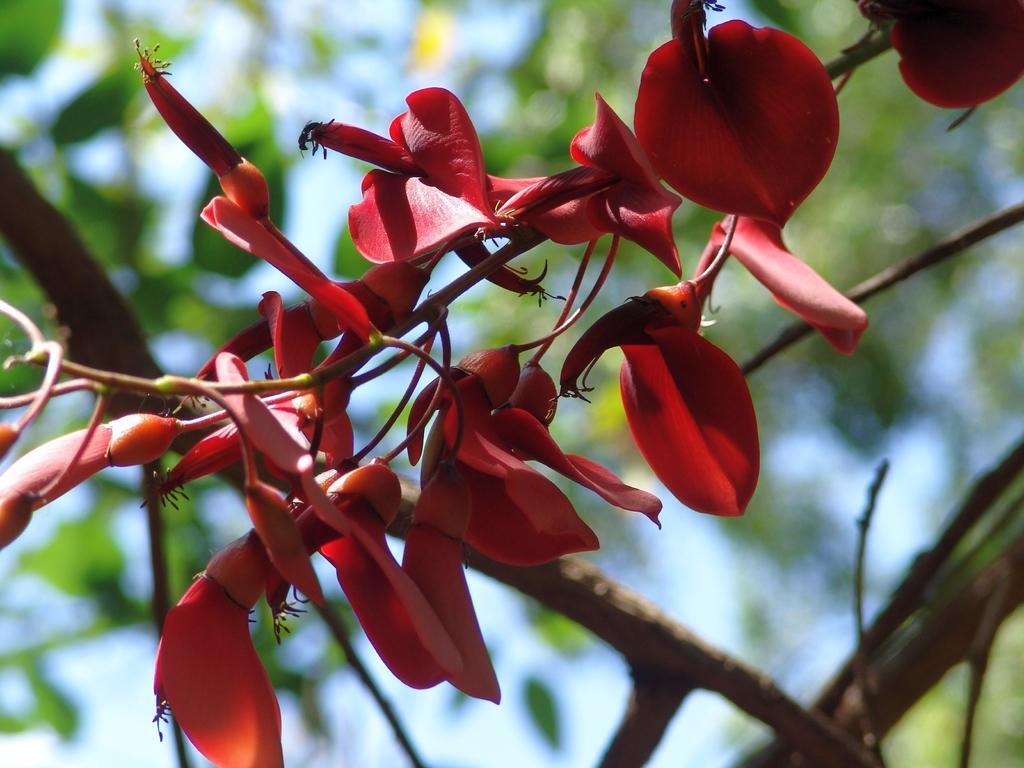Could you give a brief overview of what you see in this image? Here we can see red flowers. Background it is blur. We can see green leaves and stems. 